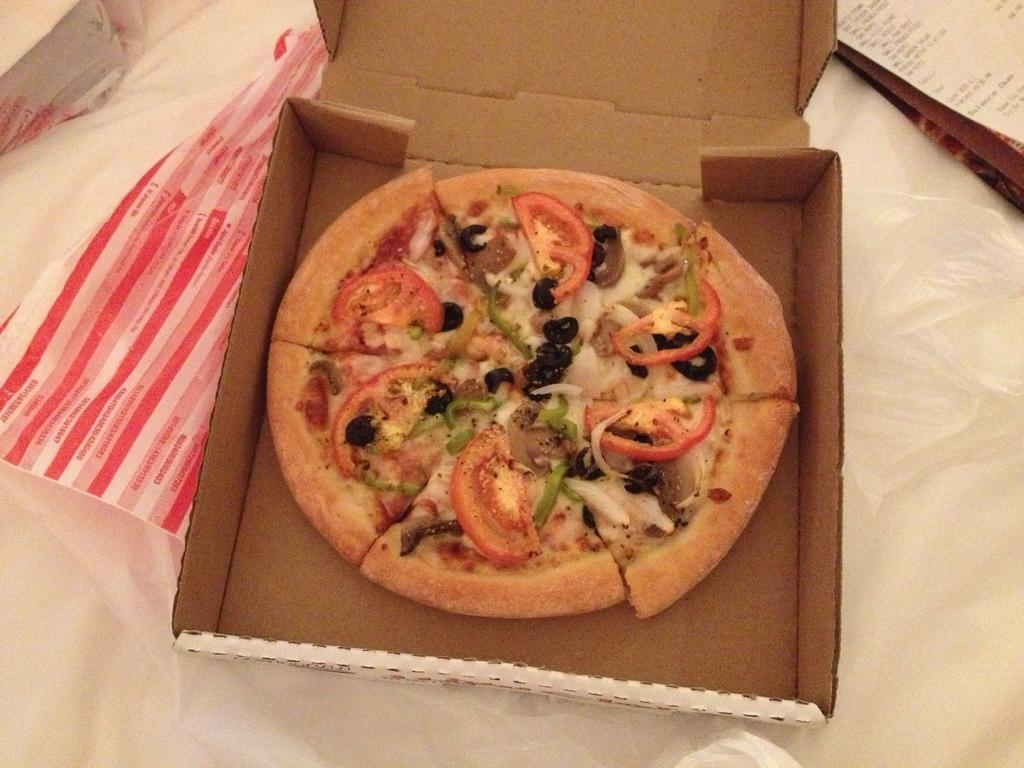What type of food is shown in the image? There is a pizza in the image. How is the pizza being stored or transported? The pizza is in a pizza box. What is the color of the surface the pizza box is on? The pizza box is on a white surface. Can you describe any other objects visible in the image? There are other objects visible in the image, but their specific details are not mentioned in the provided facts. What kind of trouble is the doll causing in the image? There is no doll present in the image, so it is not possible to answer a question about a doll causing trouble. 